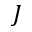<formula> <loc_0><loc_0><loc_500><loc_500>J</formula> 